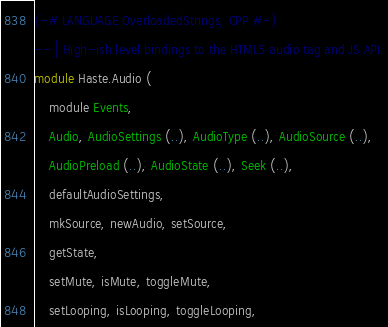Convert code to text. <code><loc_0><loc_0><loc_500><loc_500><_Haskell_>{-# LANGUAGE OverloadedStrings, CPP #-}
-- | High-ish level bindings to the HTML5 audio tag and JS API.
module Haste.Audio (
    module Events,
    Audio, AudioSettings (..), AudioType (..), AudioSource (..),
    AudioPreload (..), AudioState (..), Seek (..),
    defaultAudioSettings,
    mkSource, newAudio, setSource,
    getState,
    setMute, isMute, toggleMute,
    setLooping, isLooping, toggleLooping,</code> 